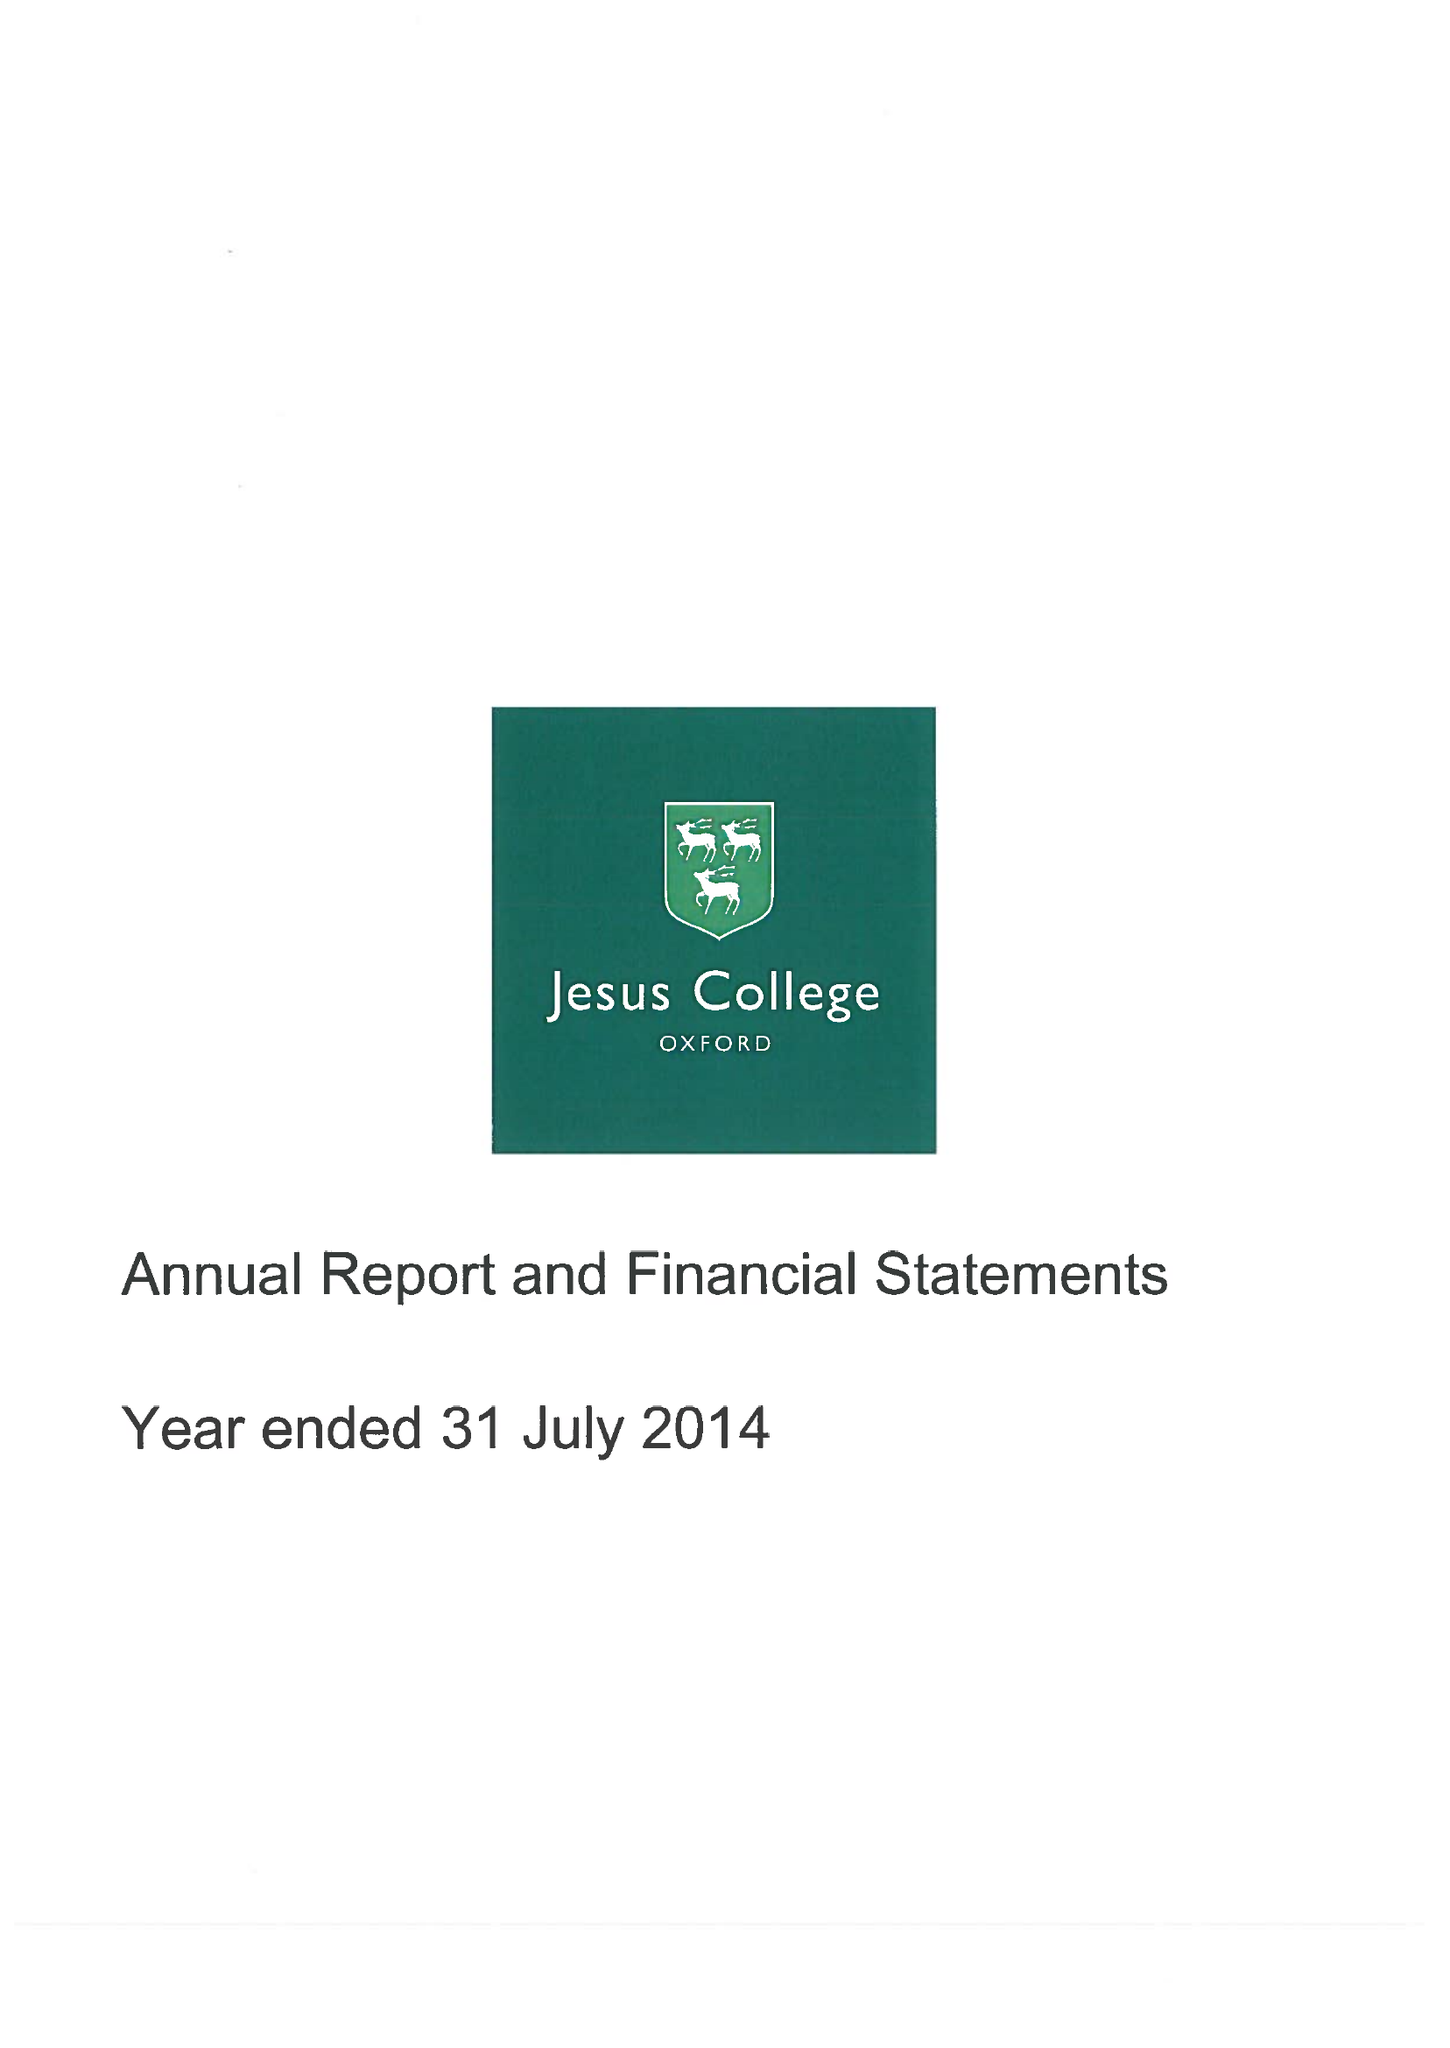What is the value for the spending_annually_in_british_pounds?
Answer the question using a single word or phrase. 11029000.00 